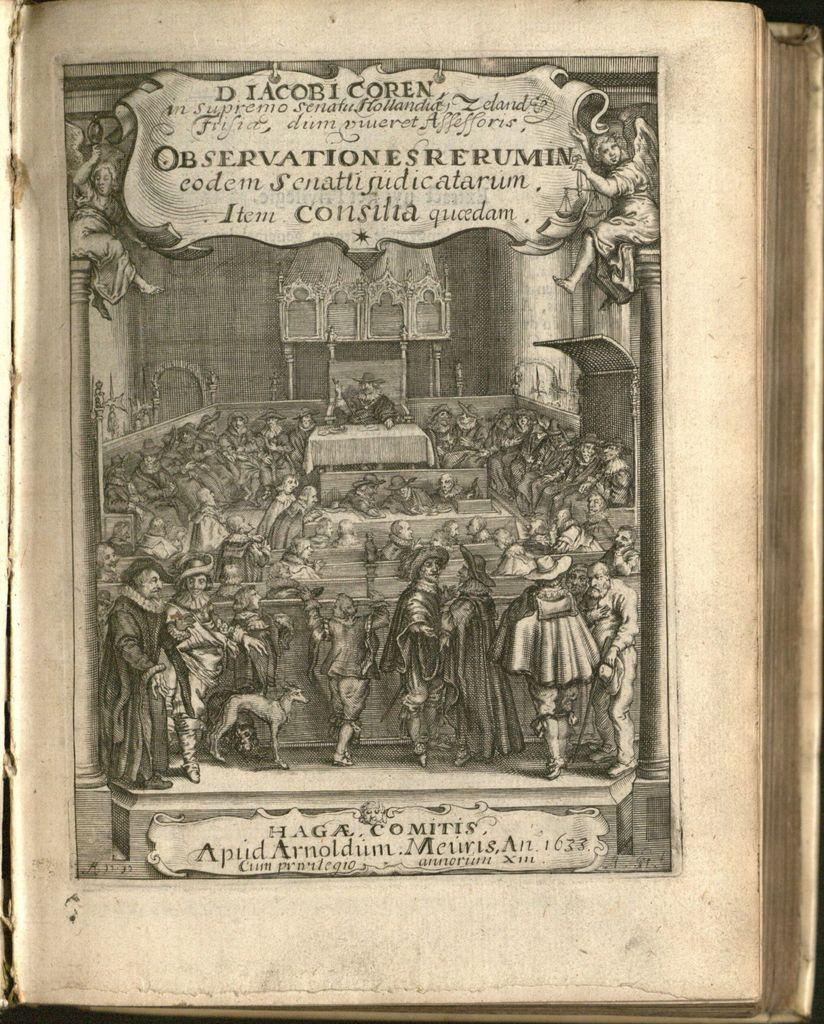<image>
Render a clear and concise summary of the photo. Book page that says "Observationesrerumin" near the top. 